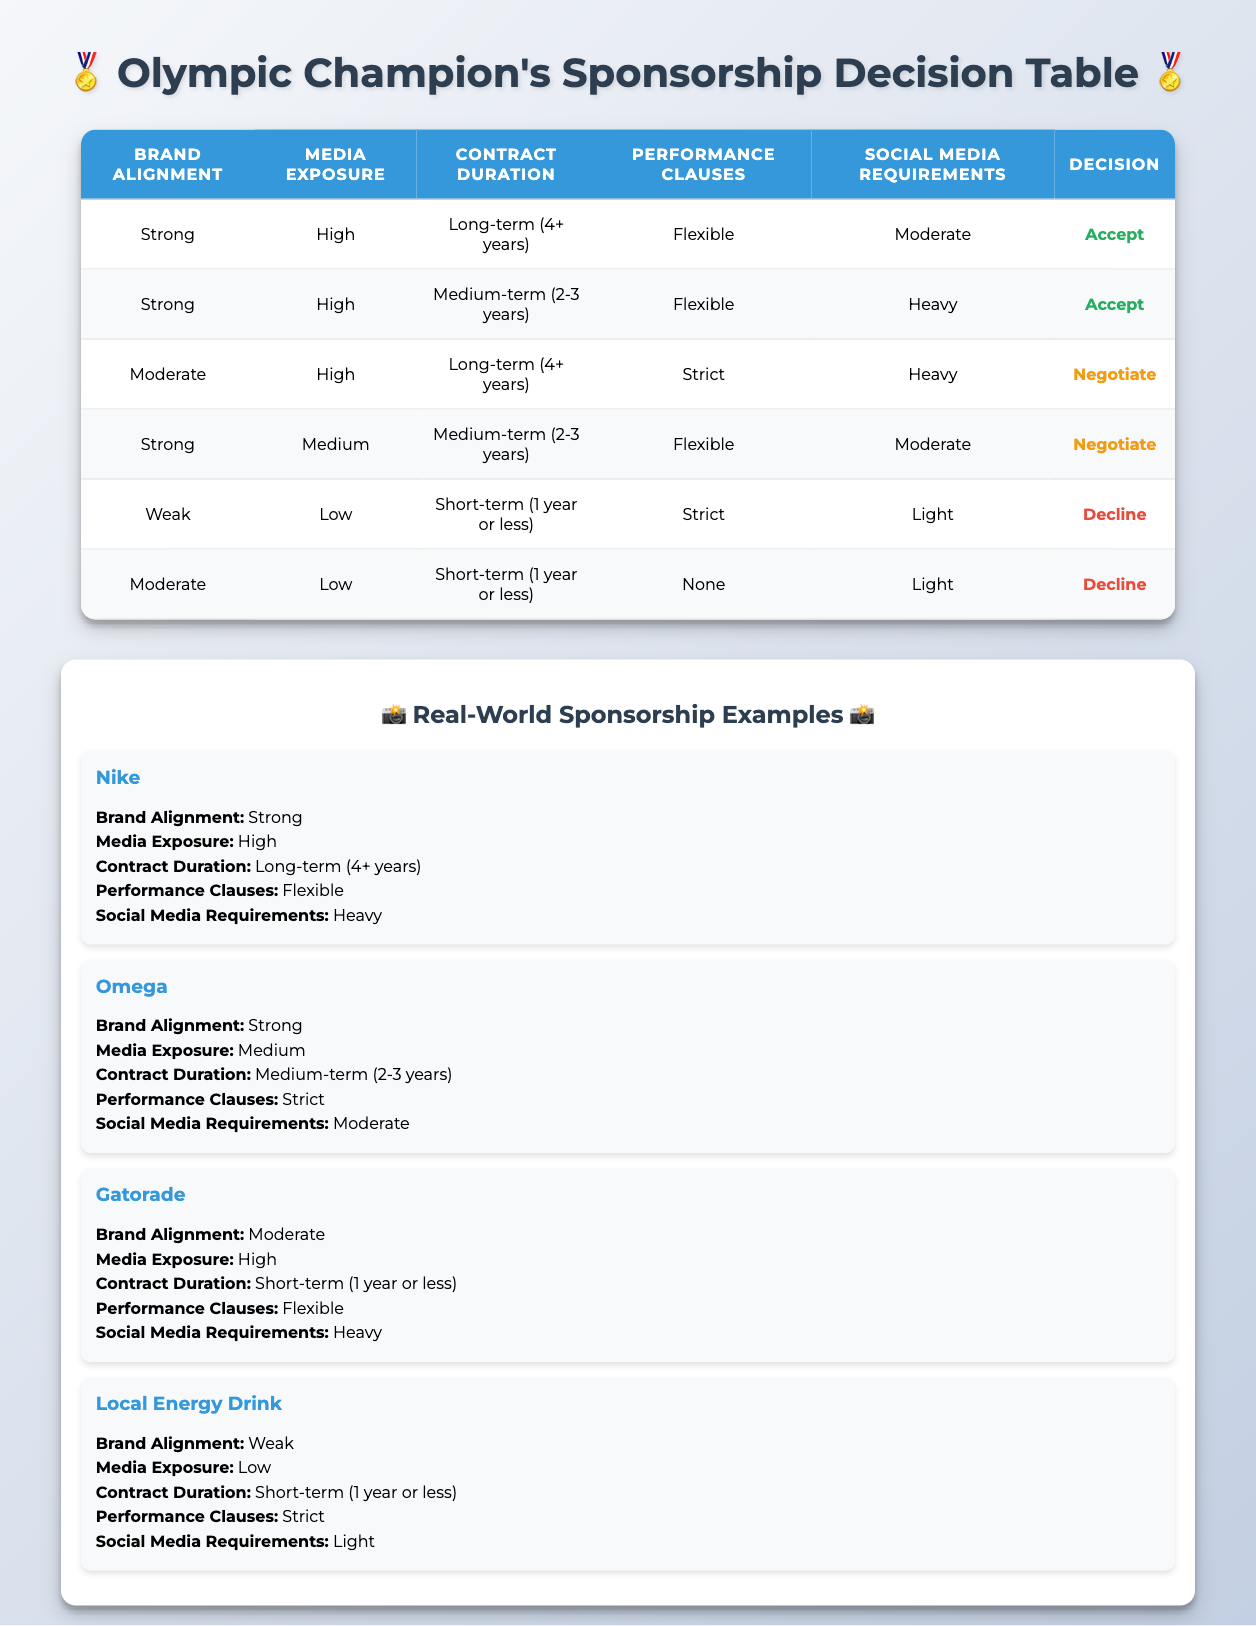What is the decision for a sponsorship with "Strong" brand alignment, "High" media exposure, and "Long-term (4+ years)" contract duration? The table shows that with these conditions, the decision is "Accept" because there is a row that matches all the specified conditions.
Answer: Accept How many sponsorship opportunities have a "Weak" brand alignment? The table displays two sponsorships with "Weak" brand alignment. They are listed in separate rows, indicating a total of two.
Answer: 2 Is it true that all sponsorships with "Strict" performance clauses lead to a decision of "Decline"? No, it is false. There is one case with "Strict" performance clauses and "High" media exposure that results in a decision to "Negotiate," showing that not all "Strict" clauses lead to a "Decline."
Answer: False What is the decision for a sponsorship with "Moderate" brand alignment, "Low" media exposure, and "Short-term (1 year or less)" contract duration? The table indicates that this specific situation leads to a decision of "Decline," as it matches one of the cases laid out in the rules.
Answer: Decline Among all sponsorships, how many have "Heavy" social media requirements and lead to an "Accept" decision? There are two sponsorships with "Heavy" social media requirements that lead to an "Accept" decision, specifically those with "Strong" brand alignment and "High" media exposure.
Answer: 2 What is the decision for a sponsorship with "Moderate" brand alignment and "Medium" media exposure? The table shows that there is a row with these conditions, which leads to a decision of "Negotiate."
Answer: Negotiate Which brand has "Strong" alignment and "Medium" media exposure while resulting in a "Negotiate" decision? The table shows the brand "Gatorade," which meets the conditions of "Strong" brand alignment, "Medium" media exposure, and results in a "Negotiate" decision.
Answer: Gatorade If a sponsorship has "Weak" brand alignment, "Low" media exposure, and "Short-term (1 year or less)" contract duration, is the decision to "Accept"? No, the decision is "Decline" for these specific conditions, as indicated in the table under the relevant rules.
Answer: No How many unique brands lead to a decision of "Accept"? There are two unique brands in the table that result in an "Accept" decision: "Nike" and "Omega." This can be confirmed by checking their conditions.
Answer: 2 